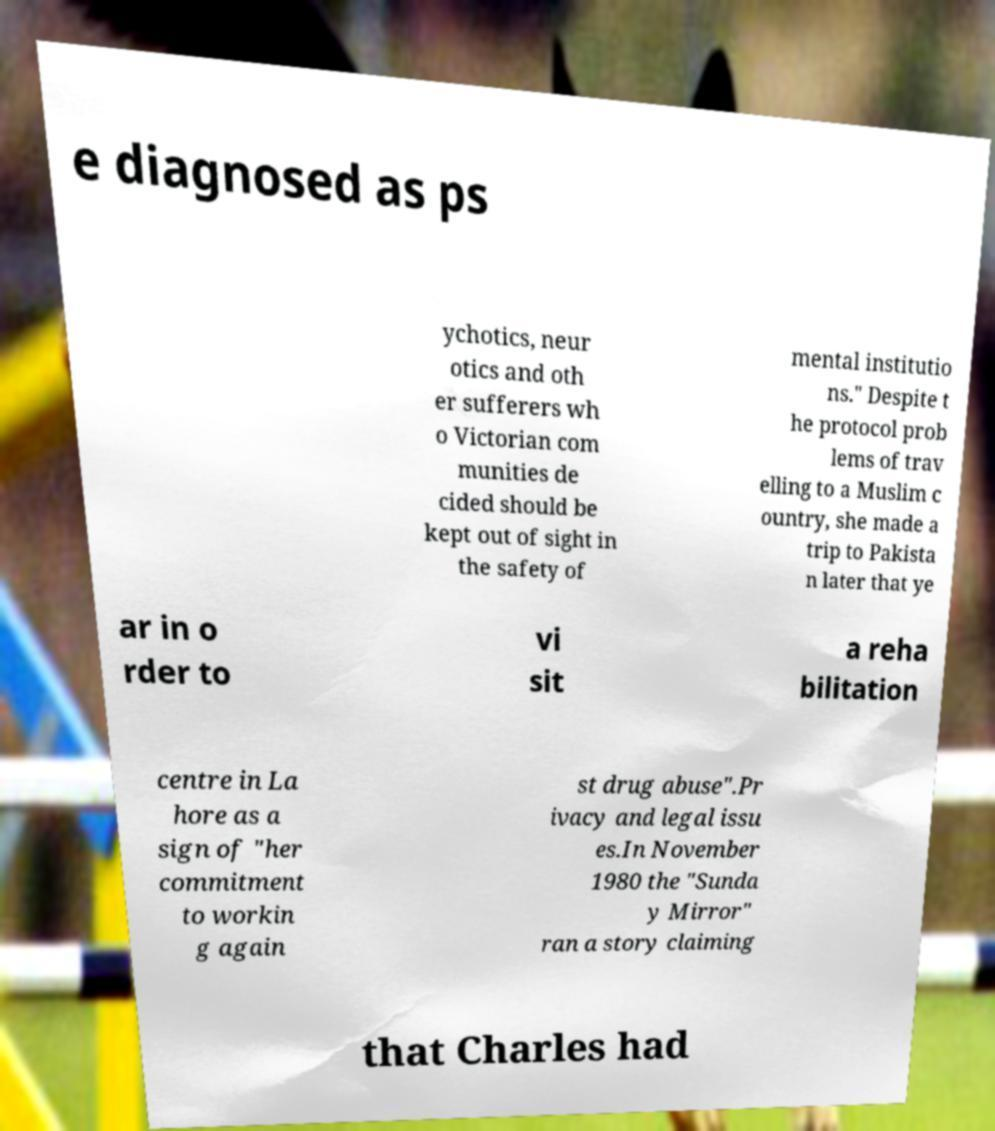Could you extract and type out the text from this image? e diagnosed as ps ychotics, neur otics and oth er sufferers wh o Victorian com munities de cided should be kept out of sight in the safety of mental institutio ns." Despite t he protocol prob lems of trav elling to a Muslim c ountry, she made a trip to Pakista n later that ye ar in o rder to vi sit a reha bilitation centre in La hore as a sign of "her commitment to workin g again st drug abuse".Pr ivacy and legal issu es.In November 1980 the "Sunda y Mirror" ran a story claiming that Charles had 